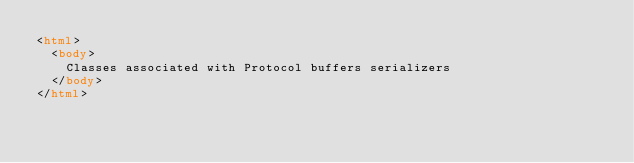<code> <loc_0><loc_0><loc_500><loc_500><_HTML_><html>
  <body>
    Classes associated with Protocol buffers serializers
  </body>
</html></code> 